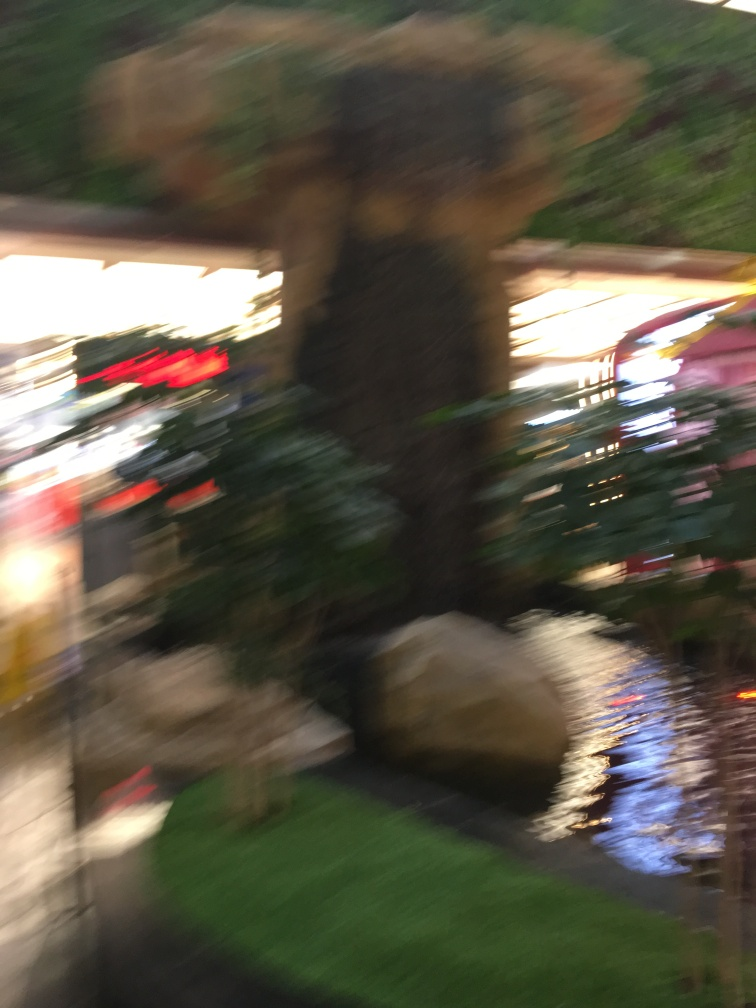Are there any quality issues with this image? The image shows significant motion blur affecting the clarity, with objects and details being indistinct and smeared. This diminishes the photo's quality, making it difficult to discern specific features or subjects within the scene. 